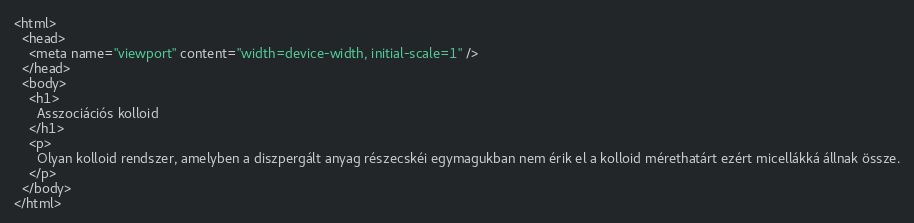<code> <loc_0><loc_0><loc_500><loc_500><_HTML_><html>
  <head>
    <meta name="viewport" content="width=device-width, initial-scale=1" />
  </head>
  <body>
    <h1>
      Asszociációs kolloid
    </h1>
    <p>
      Olyan kolloid rendszer, amelyben a diszpergált anyag részecskéi egymagukban nem érik el a kolloid mérethatárt ezért micellákká állnak össze.
    </p>
  </body>
</html>
</code> 